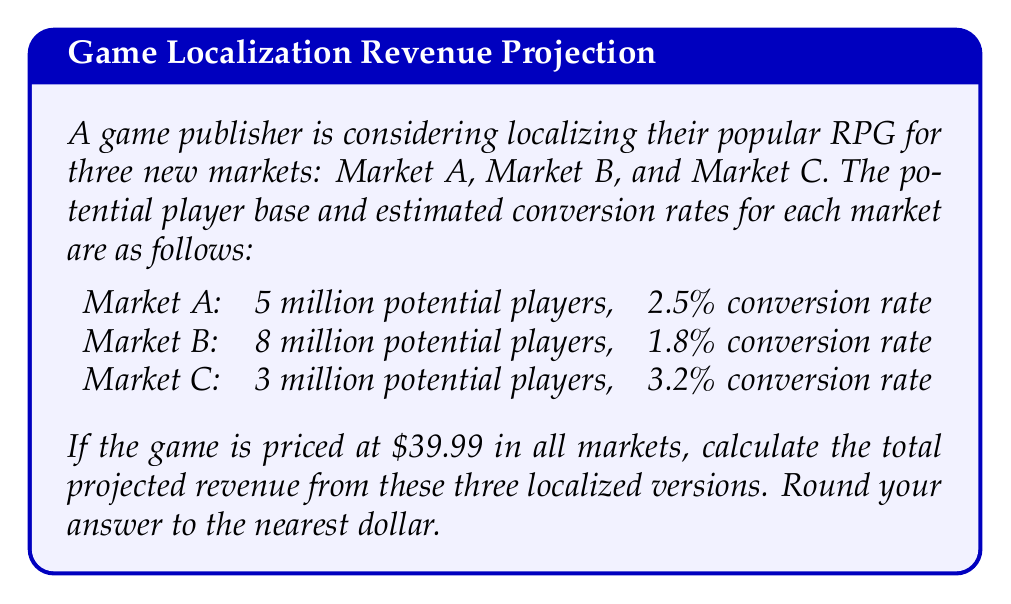Provide a solution to this math problem. To solve this problem, we'll follow these steps:

1. Calculate the number of converted players for each market:
   Market A: $5,000,000 \times 0.025 = 125,000$ players
   Market B: $8,000,000 \times 0.018 = 144,000$ players
   Market C: $3,000,000 \times 0.032 = 96,000$ players

2. Calculate the revenue for each market:
   Revenue = Number of converted players × Price per game
   
   Market A: $125,000 \times \$39.99 = \$4,998,750$
   Market B: $144,000 \times \$39.99 = \$5,758,560$
   Market C: $96,000 \times \$39.99 = \$3,839,040$

3. Sum up the revenues from all three markets:
   $$\text{Total Revenue} = \$4,998,750 + \$5,758,560 + \$3,839,040 = \$14,596,350$$

4. Round to the nearest dollar:
   $\$14,596,350$ rounded to the nearest dollar is $\$14,596,350$.

Therefore, the total projected revenue from the three localized versions is $\$14,596,350$.
Answer: $\$14,596,350$ 